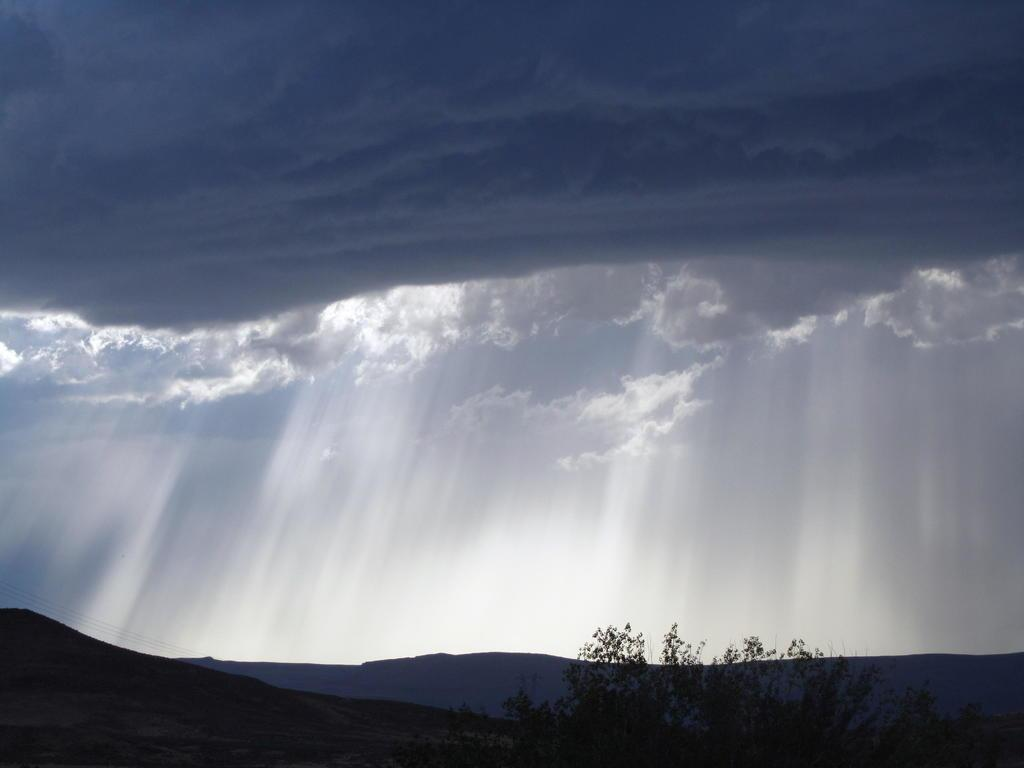What is the main feature in the center of the image? The center of the image contains the sky. What can be seen in the sky? Clouds are visible in the sky. What else is present in the image besides the sky and clouds? Sun rays, hills, and trees are present in the image. Where is the sister standing in the image? There is no sister present in the image. What type of answer can be seen written on the dock in the image? There is no dock or written answer present in the image. 